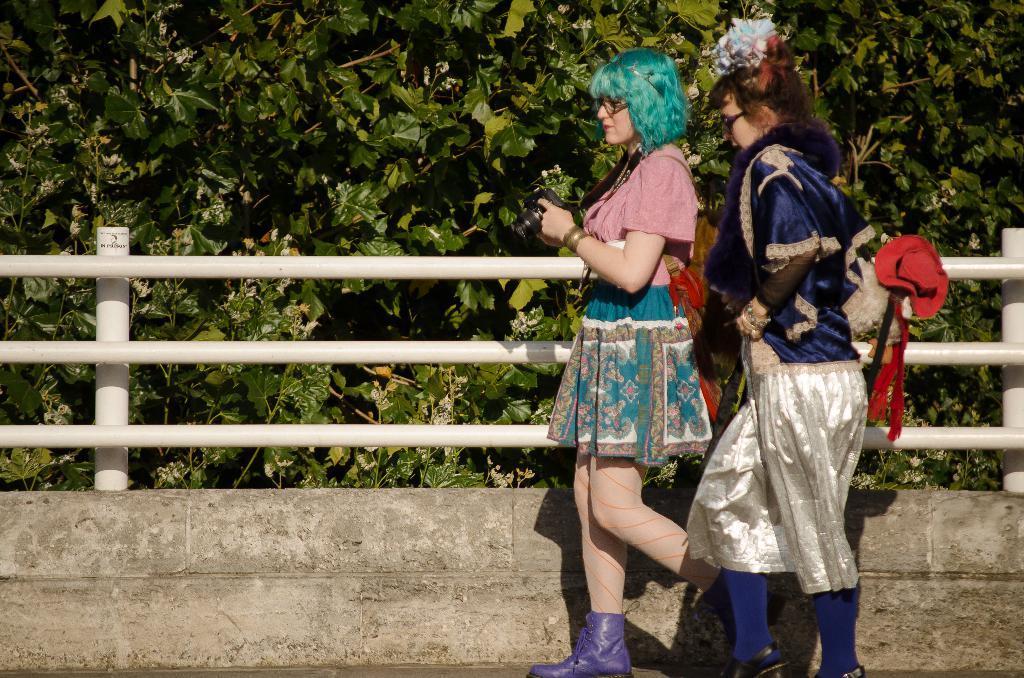In one or two sentences, can you explain what this image depicts? This image consists of two women walking on the road. In the front, we can see a railing and a wall. The railing is white in color. In the background, there are trees. 